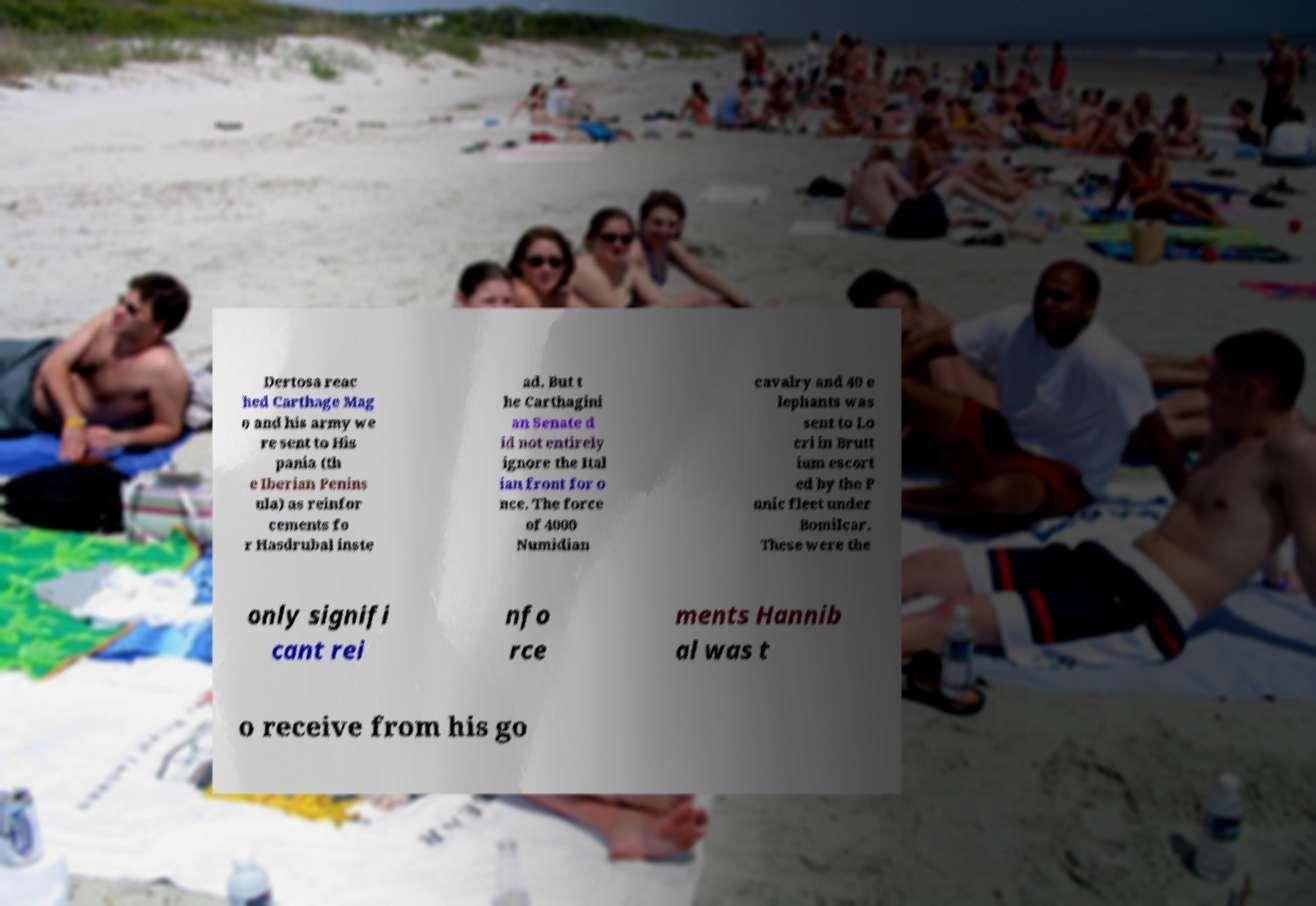Please read and relay the text visible in this image. What does it say? Dertosa reac hed Carthage Mag o and his army we re sent to His pania (th e Iberian Penins ula) as reinfor cements fo r Hasdrubal inste ad. But t he Carthagini an Senate d id not entirely ignore the Ital ian front for o nce. The force of 4000 Numidian cavalry and 40 e lephants was sent to Lo cri in Brutt ium escort ed by the P unic fleet under Bomilcar. These were the only signifi cant rei nfo rce ments Hannib al was t o receive from his go 